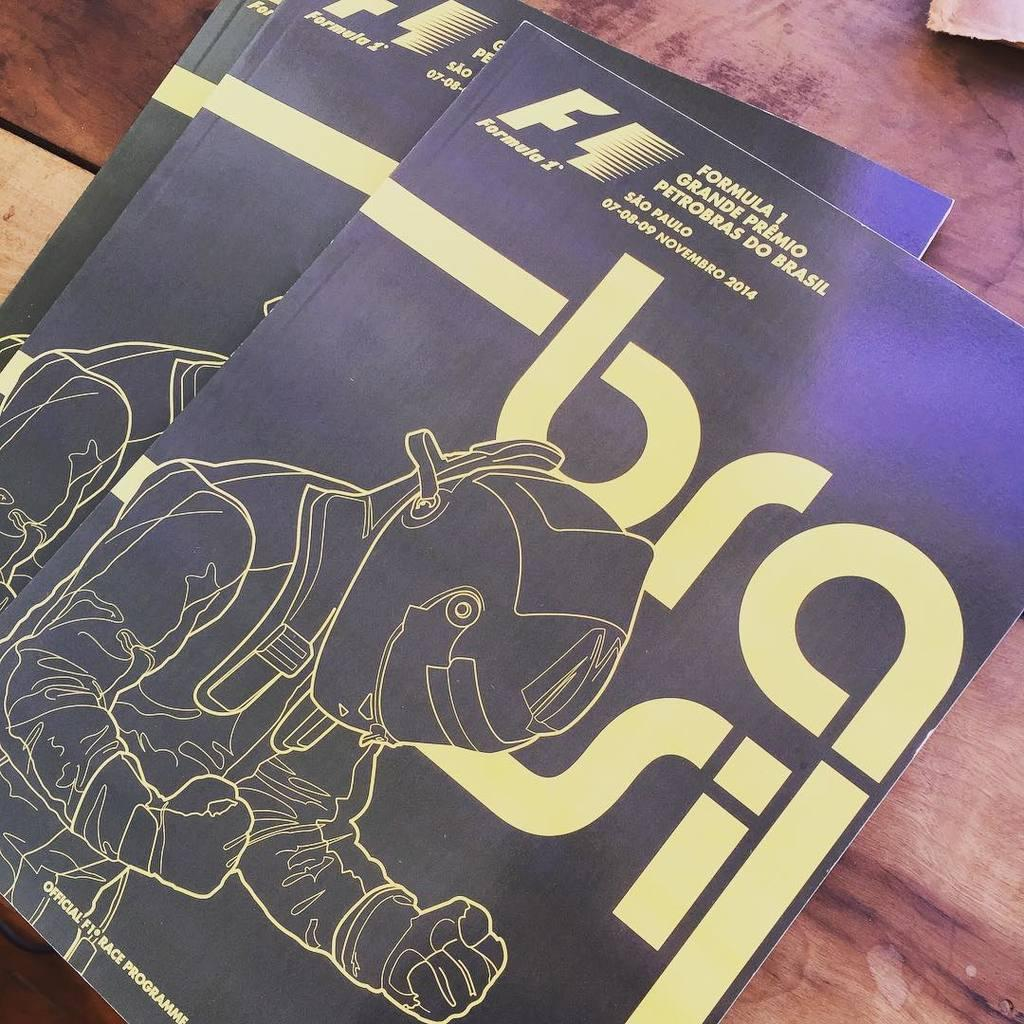<image>
Relay a brief, clear account of the picture shown. Two copies of a formula 1 brasil magazine 